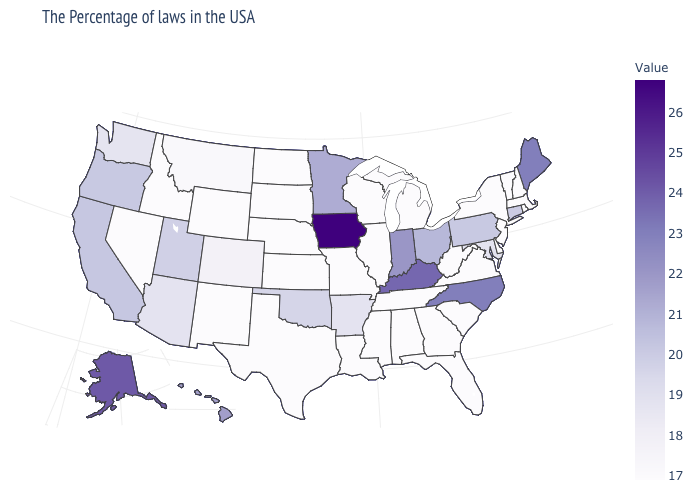Among the states that border California , which have the highest value?
Quick response, please. Oregon. Does Ohio have the lowest value in the USA?
Answer briefly. No. Among the states that border Colorado , which have the highest value?
Short answer required. Utah. 